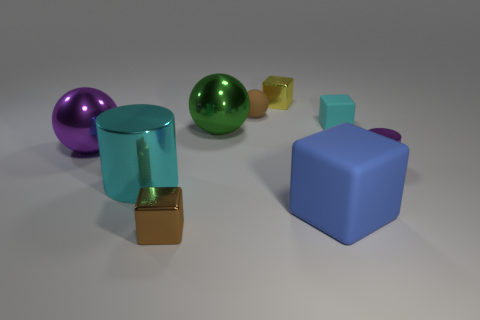There is a cyan object that is in front of the matte block that is behind the metallic sphere that is in front of the large green shiny thing; how big is it?
Your answer should be compact. Large. There is a metal block that is the same color as the rubber ball; what is its size?
Your answer should be very brief. Small. How many things are either green shiny objects or small cyan rubber objects?
Your answer should be compact. 2. There is a tiny thing that is to the right of the yellow thing and in front of the big green shiny thing; what is its shape?
Ensure brevity in your answer.  Cylinder. Does the big purple thing have the same shape as the brown object in front of the blue matte cube?
Make the answer very short. No. There is a yellow shiny block; are there any purple things in front of it?
Offer a very short reply. Yes. There is a object that is the same color as the big cylinder; what is it made of?
Keep it short and to the point. Rubber. How many balls are either big purple metallic things or small brown metallic objects?
Your answer should be compact. 1. Does the blue matte object have the same shape as the tiny brown matte object?
Provide a succinct answer. No. There is a metal cylinder that is right of the brown block; what size is it?
Keep it short and to the point. Small. 